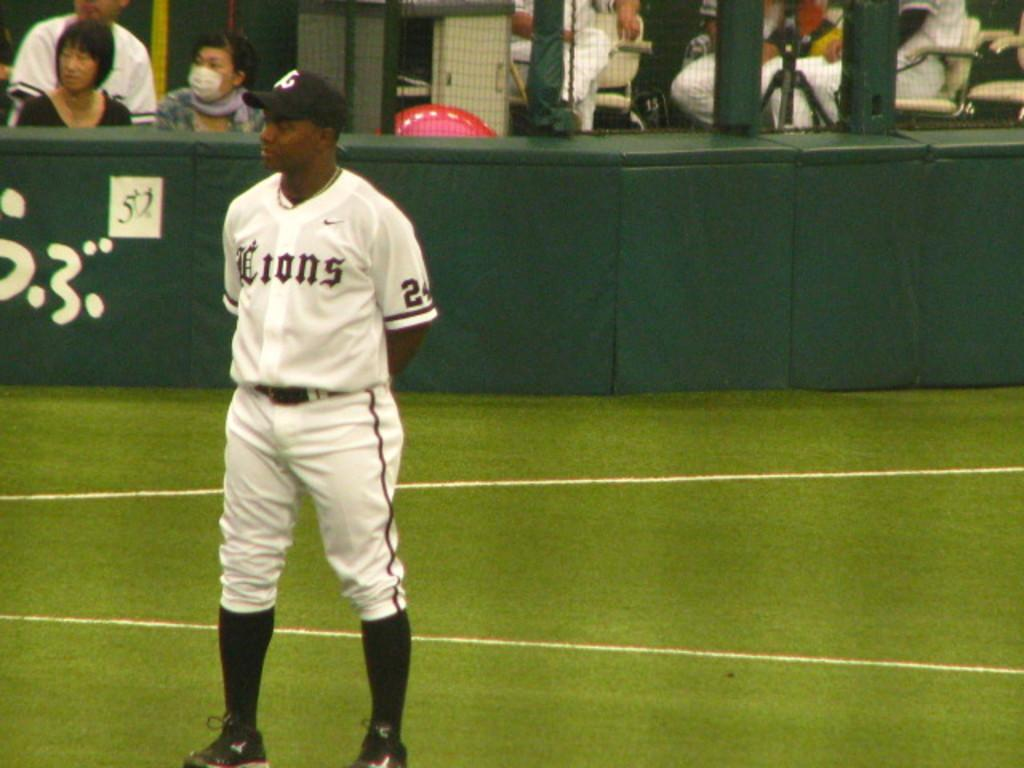<image>
Render a clear and concise summary of the photo. a man in a LIONS jersey stands on a field 